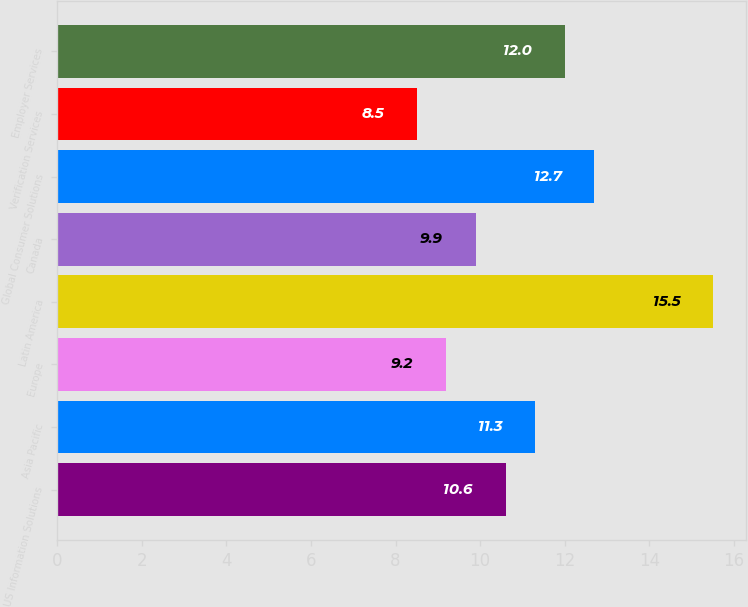Convert chart. <chart><loc_0><loc_0><loc_500><loc_500><bar_chart><fcel>US Information Solutions<fcel>Asia Pacific<fcel>Europe<fcel>Latin America<fcel>Canada<fcel>Global Consumer Solutions<fcel>Verification Services<fcel>Employer Services<nl><fcel>10.6<fcel>11.3<fcel>9.2<fcel>15.5<fcel>9.9<fcel>12.7<fcel>8.5<fcel>12<nl></chart> 